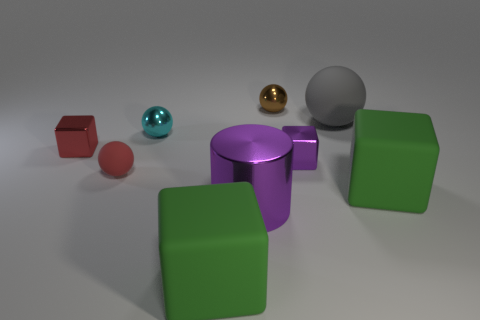Subtract all brown spheres. How many spheres are left? 3 Subtract all gray spheres. How many spheres are left? 3 Subtract all big shiny things. Subtract all small purple metallic objects. How many objects are left? 7 Add 2 small brown metallic spheres. How many small brown metallic spheres are left? 3 Add 6 big brown matte things. How many big brown matte things exist? 6 Subtract 0 green cylinders. How many objects are left? 9 Subtract all cylinders. How many objects are left? 8 Subtract 1 cylinders. How many cylinders are left? 0 Subtract all blue balls. Subtract all brown cylinders. How many balls are left? 4 Subtract all cyan blocks. How many gray balls are left? 1 